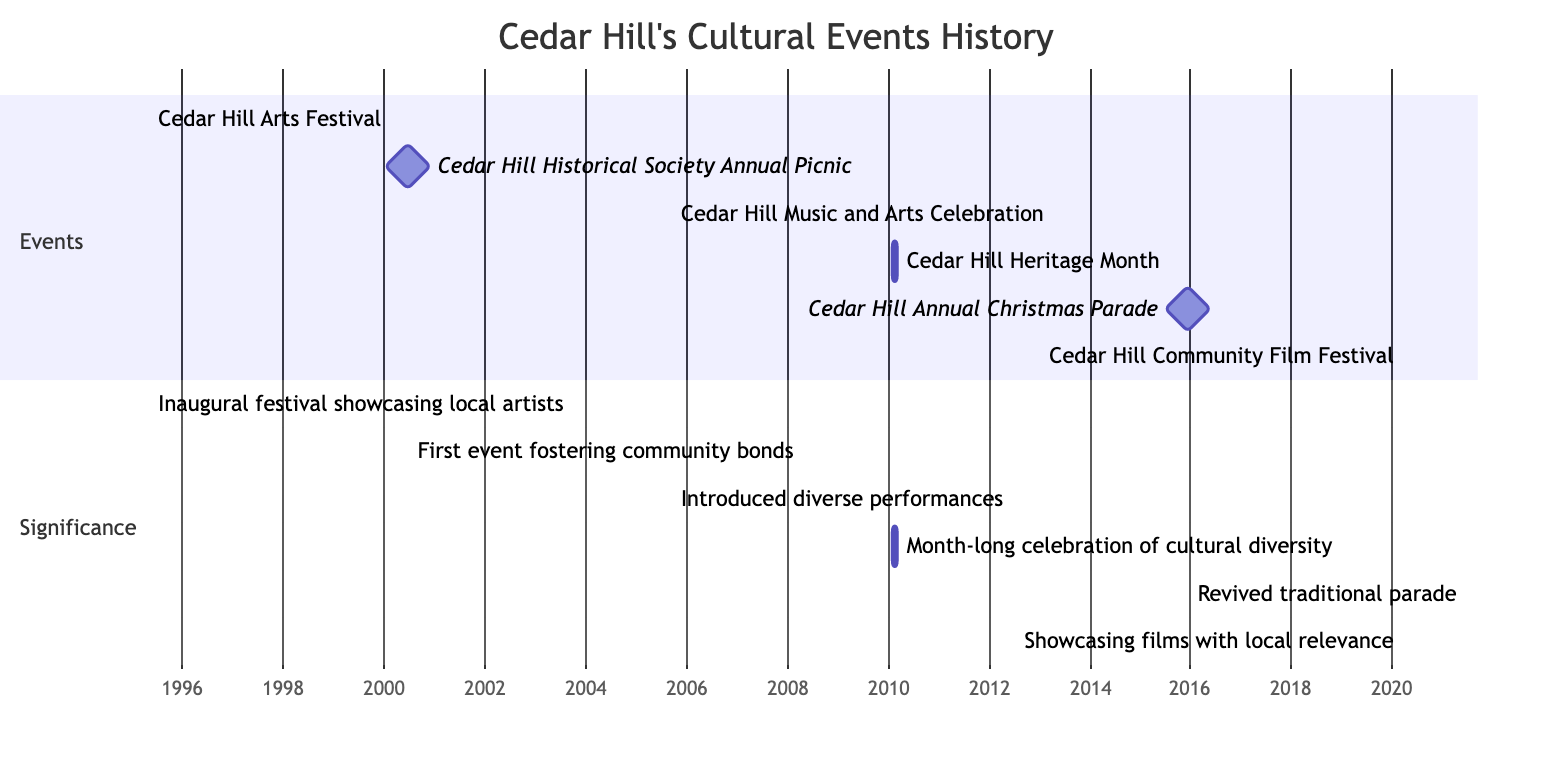What is the duration of the Cedar Hill Arts Festival? The Cedar Hill Arts Festival is shown as an event starting on May 1, 1995, and ending on May 3, 1995. To find the duration, we count the number of days from the start to the end date, which includes three days: May 1, 2, and 3.
Answer: 3 days What year did the Cedar Hill Heritage Month take place? The Cedar Hill Heritage Month is depicted on the Gantt chart with a start date of February 1, 2010, and an end date of February 28, 2010. Therefore, the year for this event is clearly shown as 2010.
Answer: 2010 Which event occurred closest to the Cedar Hill Music and Arts Celebration? The Cedar Hill Music and Arts Celebration took place from September 10 to September 12, 2005. The next event after that is the Cedar Hill Heritage Month, which started on February 1, 2010. There is a gap of several years, but it can be determined that the Cedar Hill Historical Society Annual Picnic, a milestone event, occurs next in 2000. Since it focuses on finding the event closest in time, the answer will be the Cedar Hill Historical Society Annual Picnic in 2000.
Answer: Cedar Hill Historical Society Annual Picnic How many total events are depicted in the diagram? The Gantt chart lists a total of six events in the 'Events' section and their corresponding significance in the 'Significance' section. By counting each event on the chart, we find that there are total of six events.
Answer: 6 Which event has the significance of showcasing films with local relevance? The Gantt chart denotes the Cedar Hill Community Film Festival as showcasing films with local relevance, starting on March 20, 2020, and ending on March 22, 2020. That is clearly labeled under its significance.
Answer: Cedar Hill Community Film Festival What event signifies the introduction of a more diverse range of performances? According to the Gantt chart, the Cedar Hill Music and Arts Celebration, which took place from September 10 to September 12 in 2005, signifies the introduction of a more diverse range of performances to the community. This information is included in the significance section of the diagram.
Answer: Cedar Hill Music and Arts Celebration In which decade was the Cedar Hill Annual Christmas Parade revived? The Cedar Hill Annual Christmas Parade is represented on the chart as occurring on December 12, 2015, which falls within the 2010s decade.
Answer: 2010s What is the milestone event that took place on June 15, 2000? The milestone event scheduled on June 15, 2000, is the Cedar Hill Historical Society Annual Picnic, indicated as a single-day event within the Gantt chart and specifically marked as a milestone.
Answer: Cedar Hill Historical Society Annual Picnic 